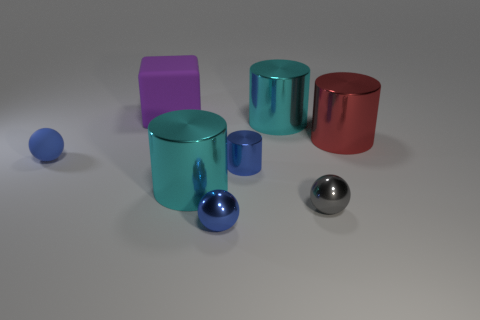Are there any other things that have the same shape as the purple thing?
Ensure brevity in your answer.  No. Are there the same number of large red objects that are behind the tiny gray ball and large green cylinders?
Offer a very short reply. No. What material is the cyan thing that is on the left side of the big cyan shiny thing behind the blue ball behind the small gray object?
Your answer should be very brief. Metal. The gray thing that is the same material as the large red thing is what shape?
Your response must be concise. Sphere. Are there any other things of the same color as the small matte ball?
Your response must be concise. Yes. How many large red shiny objects are in front of the tiny blue ball that is on the left side of the cyan thing in front of the tiny rubber thing?
Provide a succinct answer. 0. How many purple objects are either large rubber balls or cylinders?
Your answer should be very brief. 0. There is a gray shiny ball; does it have the same size as the purple matte thing that is behind the blue matte object?
Ensure brevity in your answer.  No. What material is the tiny thing that is the same shape as the big red metallic object?
Offer a very short reply. Metal. How many other objects are there of the same size as the cube?
Keep it short and to the point. 3. 